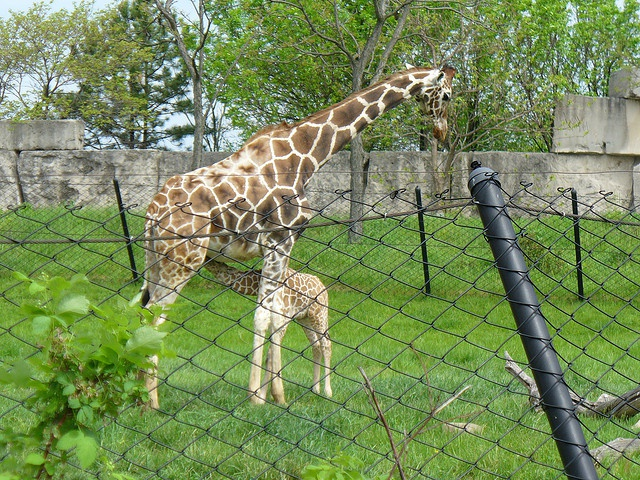Describe the objects in this image and their specific colors. I can see giraffe in white, tan, ivory, and gray tones and giraffe in white, olive, ivory, tan, and gray tones in this image. 